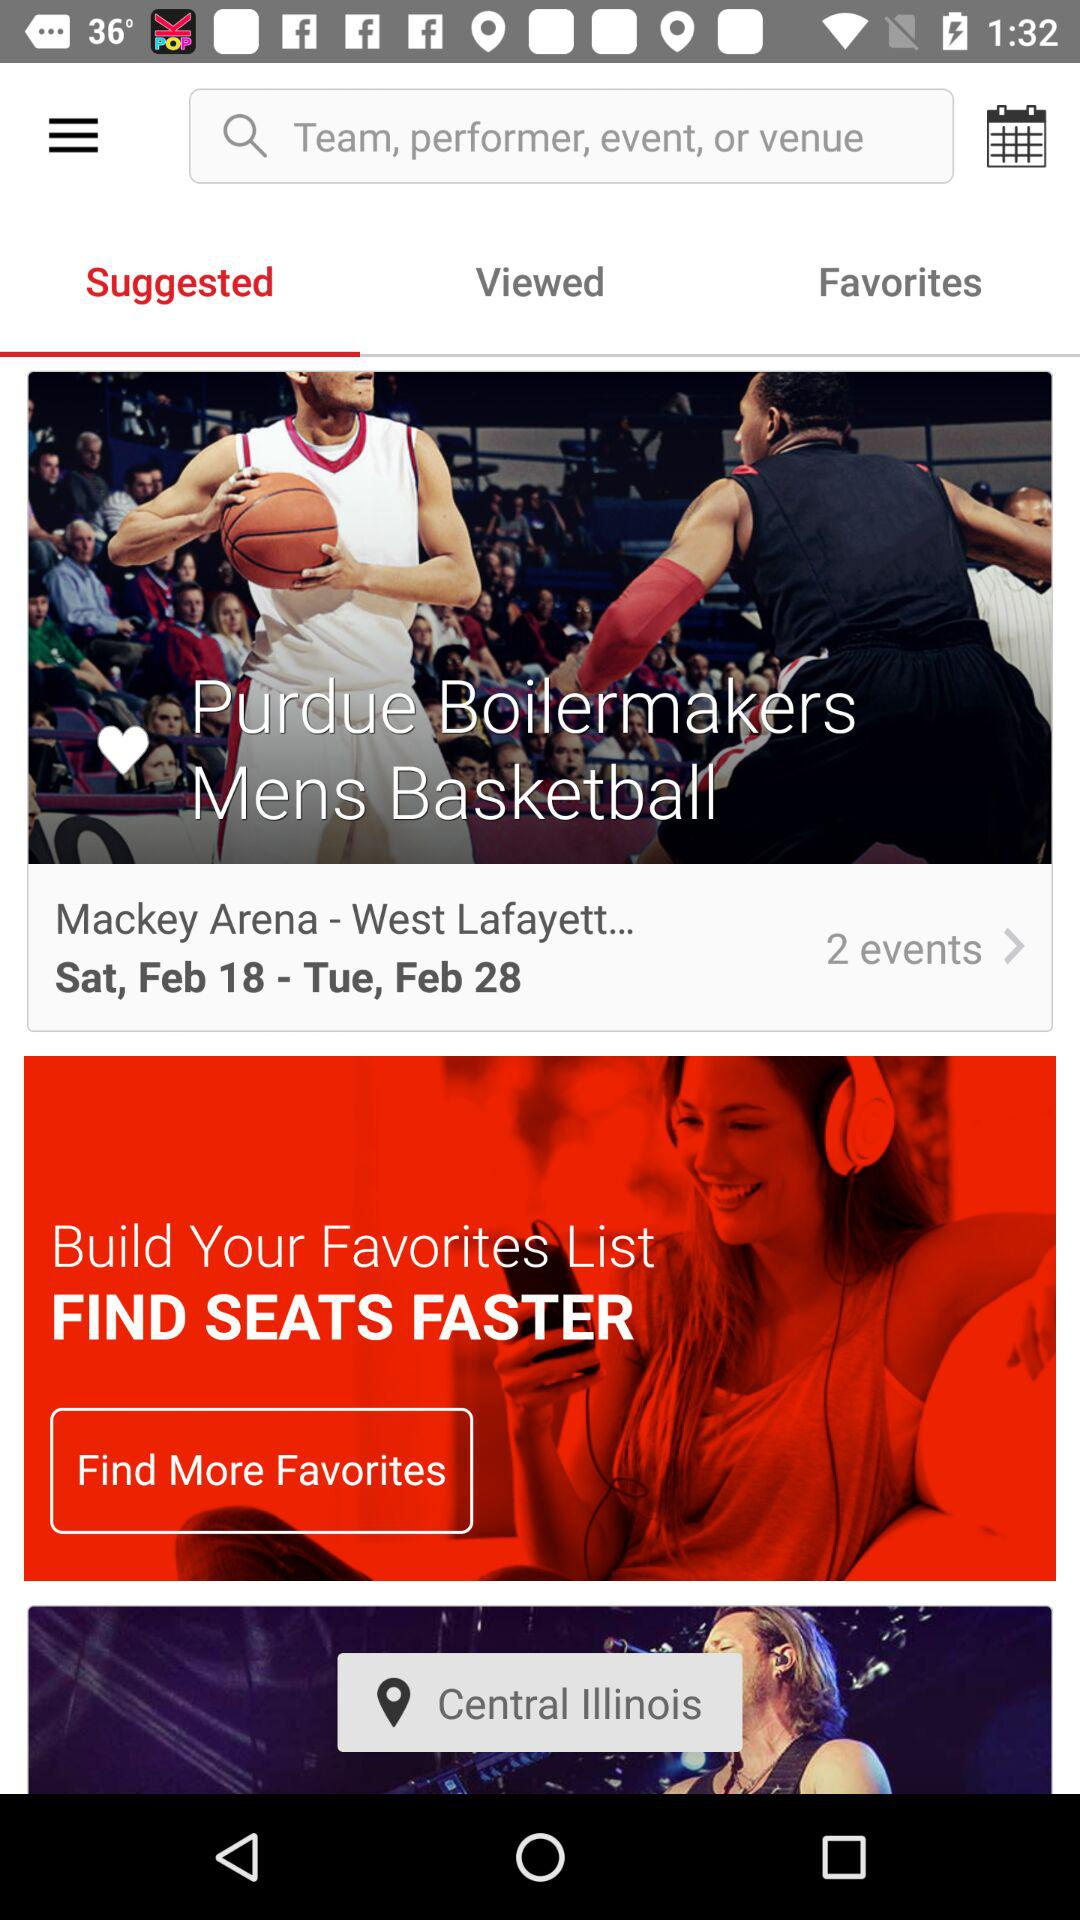What are the dates for the events? The dates for the events are from Saturday, February 18 to Tuesday, February 28. 